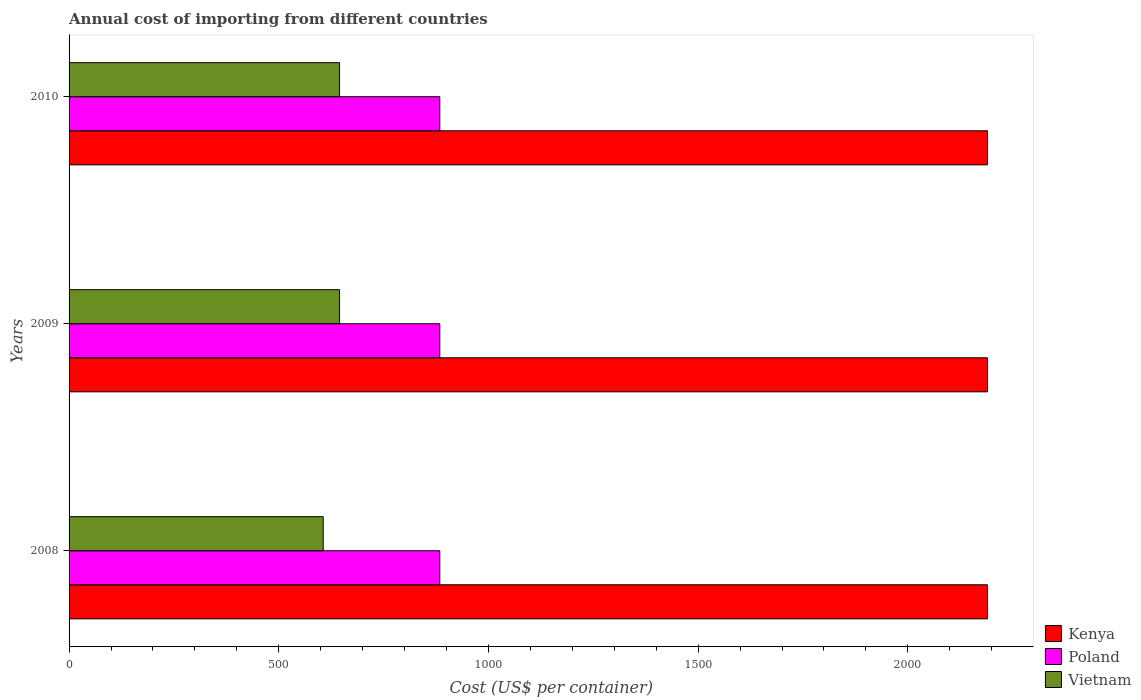How many groups of bars are there?
Your response must be concise. 3. How many bars are there on the 1st tick from the bottom?
Your response must be concise. 3. What is the total annual cost of importing in Poland in 2009?
Your response must be concise. 884. Across all years, what is the maximum total annual cost of importing in Vietnam?
Offer a terse response. 645. Across all years, what is the minimum total annual cost of importing in Vietnam?
Provide a succinct answer. 606. What is the total total annual cost of importing in Poland in the graph?
Keep it short and to the point. 2652. What is the difference between the total annual cost of importing in Poland in 2010 and the total annual cost of importing in Kenya in 2009?
Offer a very short reply. -1306. What is the average total annual cost of importing in Poland per year?
Your answer should be very brief. 884. In the year 2008, what is the difference between the total annual cost of importing in Kenya and total annual cost of importing in Poland?
Keep it short and to the point. 1306. In how many years, is the total annual cost of importing in Poland greater than 300 US$?
Give a very brief answer. 3. What is the ratio of the total annual cost of importing in Poland in 2009 to that in 2010?
Make the answer very short. 1. Is the total annual cost of importing in Kenya in 2008 less than that in 2009?
Your response must be concise. No. Is the difference between the total annual cost of importing in Kenya in 2008 and 2009 greater than the difference between the total annual cost of importing in Poland in 2008 and 2009?
Provide a short and direct response. No. What is the difference between the highest and the lowest total annual cost of importing in Kenya?
Ensure brevity in your answer.  0. In how many years, is the total annual cost of importing in Poland greater than the average total annual cost of importing in Poland taken over all years?
Offer a terse response. 0. What does the 3rd bar from the top in 2010 represents?
Your answer should be very brief. Kenya. What does the 3rd bar from the bottom in 2008 represents?
Make the answer very short. Vietnam. Is it the case that in every year, the sum of the total annual cost of importing in Vietnam and total annual cost of importing in Poland is greater than the total annual cost of importing in Kenya?
Keep it short and to the point. No. How many years are there in the graph?
Your response must be concise. 3. Are the values on the major ticks of X-axis written in scientific E-notation?
Provide a short and direct response. No. Where does the legend appear in the graph?
Your answer should be compact. Bottom right. How many legend labels are there?
Ensure brevity in your answer.  3. How are the legend labels stacked?
Your response must be concise. Vertical. What is the title of the graph?
Offer a terse response. Annual cost of importing from different countries. Does "Europe(all income levels)" appear as one of the legend labels in the graph?
Keep it short and to the point. No. What is the label or title of the X-axis?
Ensure brevity in your answer.  Cost (US$ per container). What is the label or title of the Y-axis?
Offer a terse response. Years. What is the Cost (US$ per container) in Kenya in 2008?
Keep it short and to the point. 2190. What is the Cost (US$ per container) of Poland in 2008?
Your response must be concise. 884. What is the Cost (US$ per container) of Vietnam in 2008?
Your answer should be very brief. 606. What is the Cost (US$ per container) of Kenya in 2009?
Your answer should be compact. 2190. What is the Cost (US$ per container) in Poland in 2009?
Keep it short and to the point. 884. What is the Cost (US$ per container) in Vietnam in 2009?
Your answer should be very brief. 645. What is the Cost (US$ per container) in Kenya in 2010?
Offer a very short reply. 2190. What is the Cost (US$ per container) of Poland in 2010?
Provide a short and direct response. 884. What is the Cost (US$ per container) of Vietnam in 2010?
Provide a short and direct response. 645. Across all years, what is the maximum Cost (US$ per container) in Kenya?
Your answer should be very brief. 2190. Across all years, what is the maximum Cost (US$ per container) of Poland?
Offer a very short reply. 884. Across all years, what is the maximum Cost (US$ per container) of Vietnam?
Keep it short and to the point. 645. Across all years, what is the minimum Cost (US$ per container) of Kenya?
Offer a terse response. 2190. Across all years, what is the minimum Cost (US$ per container) of Poland?
Keep it short and to the point. 884. Across all years, what is the minimum Cost (US$ per container) of Vietnam?
Provide a succinct answer. 606. What is the total Cost (US$ per container) of Kenya in the graph?
Offer a terse response. 6570. What is the total Cost (US$ per container) in Poland in the graph?
Give a very brief answer. 2652. What is the total Cost (US$ per container) of Vietnam in the graph?
Give a very brief answer. 1896. What is the difference between the Cost (US$ per container) of Poland in 2008 and that in 2009?
Make the answer very short. 0. What is the difference between the Cost (US$ per container) of Vietnam in 2008 and that in 2009?
Offer a terse response. -39. What is the difference between the Cost (US$ per container) of Kenya in 2008 and that in 2010?
Your answer should be very brief. 0. What is the difference between the Cost (US$ per container) of Poland in 2008 and that in 2010?
Offer a terse response. 0. What is the difference between the Cost (US$ per container) in Vietnam in 2008 and that in 2010?
Make the answer very short. -39. What is the difference between the Cost (US$ per container) in Kenya in 2008 and the Cost (US$ per container) in Poland in 2009?
Offer a terse response. 1306. What is the difference between the Cost (US$ per container) of Kenya in 2008 and the Cost (US$ per container) of Vietnam in 2009?
Keep it short and to the point. 1545. What is the difference between the Cost (US$ per container) of Poland in 2008 and the Cost (US$ per container) of Vietnam in 2009?
Your answer should be compact. 239. What is the difference between the Cost (US$ per container) of Kenya in 2008 and the Cost (US$ per container) of Poland in 2010?
Your answer should be very brief. 1306. What is the difference between the Cost (US$ per container) in Kenya in 2008 and the Cost (US$ per container) in Vietnam in 2010?
Offer a very short reply. 1545. What is the difference between the Cost (US$ per container) in Poland in 2008 and the Cost (US$ per container) in Vietnam in 2010?
Your response must be concise. 239. What is the difference between the Cost (US$ per container) of Kenya in 2009 and the Cost (US$ per container) of Poland in 2010?
Give a very brief answer. 1306. What is the difference between the Cost (US$ per container) in Kenya in 2009 and the Cost (US$ per container) in Vietnam in 2010?
Your answer should be compact. 1545. What is the difference between the Cost (US$ per container) in Poland in 2009 and the Cost (US$ per container) in Vietnam in 2010?
Offer a terse response. 239. What is the average Cost (US$ per container) of Kenya per year?
Make the answer very short. 2190. What is the average Cost (US$ per container) of Poland per year?
Give a very brief answer. 884. What is the average Cost (US$ per container) in Vietnam per year?
Keep it short and to the point. 632. In the year 2008, what is the difference between the Cost (US$ per container) in Kenya and Cost (US$ per container) in Poland?
Make the answer very short. 1306. In the year 2008, what is the difference between the Cost (US$ per container) of Kenya and Cost (US$ per container) of Vietnam?
Offer a very short reply. 1584. In the year 2008, what is the difference between the Cost (US$ per container) in Poland and Cost (US$ per container) in Vietnam?
Keep it short and to the point. 278. In the year 2009, what is the difference between the Cost (US$ per container) of Kenya and Cost (US$ per container) of Poland?
Your answer should be very brief. 1306. In the year 2009, what is the difference between the Cost (US$ per container) in Kenya and Cost (US$ per container) in Vietnam?
Provide a succinct answer. 1545. In the year 2009, what is the difference between the Cost (US$ per container) of Poland and Cost (US$ per container) of Vietnam?
Offer a terse response. 239. In the year 2010, what is the difference between the Cost (US$ per container) in Kenya and Cost (US$ per container) in Poland?
Your answer should be compact. 1306. In the year 2010, what is the difference between the Cost (US$ per container) of Kenya and Cost (US$ per container) of Vietnam?
Your response must be concise. 1545. In the year 2010, what is the difference between the Cost (US$ per container) of Poland and Cost (US$ per container) of Vietnam?
Your answer should be very brief. 239. What is the ratio of the Cost (US$ per container) of Poland in 2008 to that in 2009?
Your response must be concise. 1. What is the ratio of the Cost (US$ per container) of Vietnam in 2008 to that in 2009?
Offer a very short reply. 0.94. What is the ratio of the Cost (US$ per container) of Vietnam in 2008 to that in 2010?
Keep it short and to the point. 0.94. What is the ratio of the Cost (US$ per container) in Kenya in 2009 to that in 2010?
Offer a very short reply. 1. What is the ratio of the Cost (US$ per container) of Poland in 2009 to that in 2010?
Offer a very short reply. 1. What is the difference between the highest and the second highest Cost (US$ per container) of Kenya?
Provide a succinct answer. 0. What is the difference between the highest and the second highest Cost (US$ per container) of Poland?
Your answer should be compact. 0. What is the difference between the highest and the lowest Cost (US$ per container) in Kenya?
Offer a terse response. 0. What is the difference between the highest and the lowest Cost (US$ per container) of Poland?
Your response must be concise. 0. 